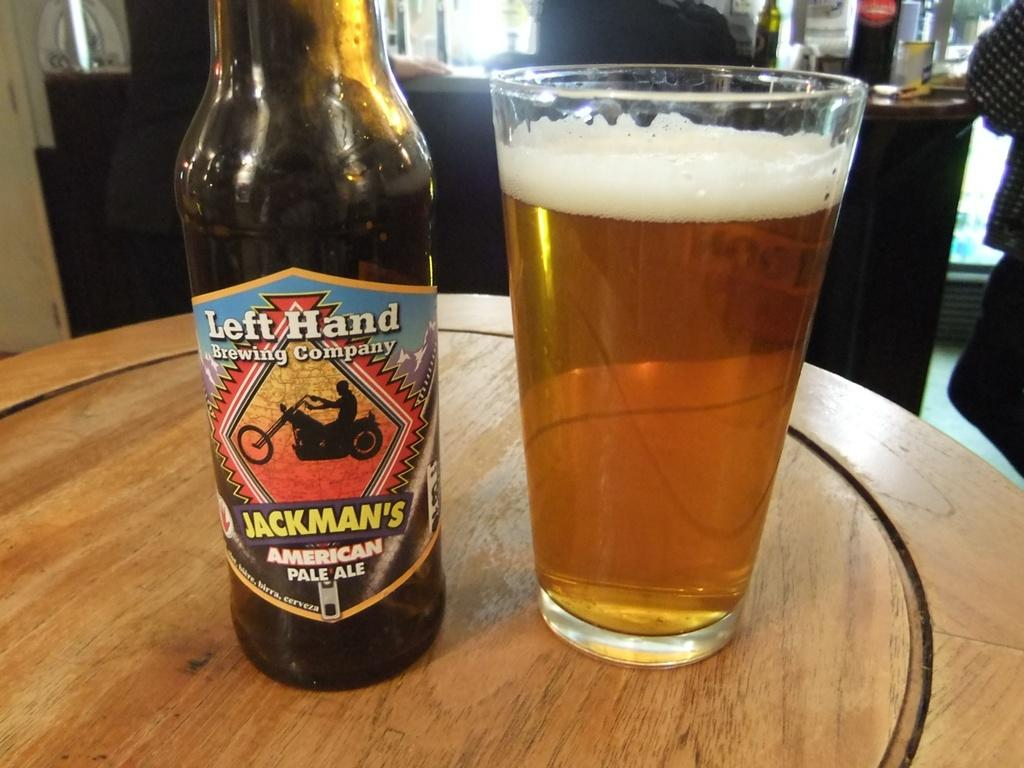Provide a one-sentence caption for the provided image. A bottle of Jackman's American pale ale next to a glass. 